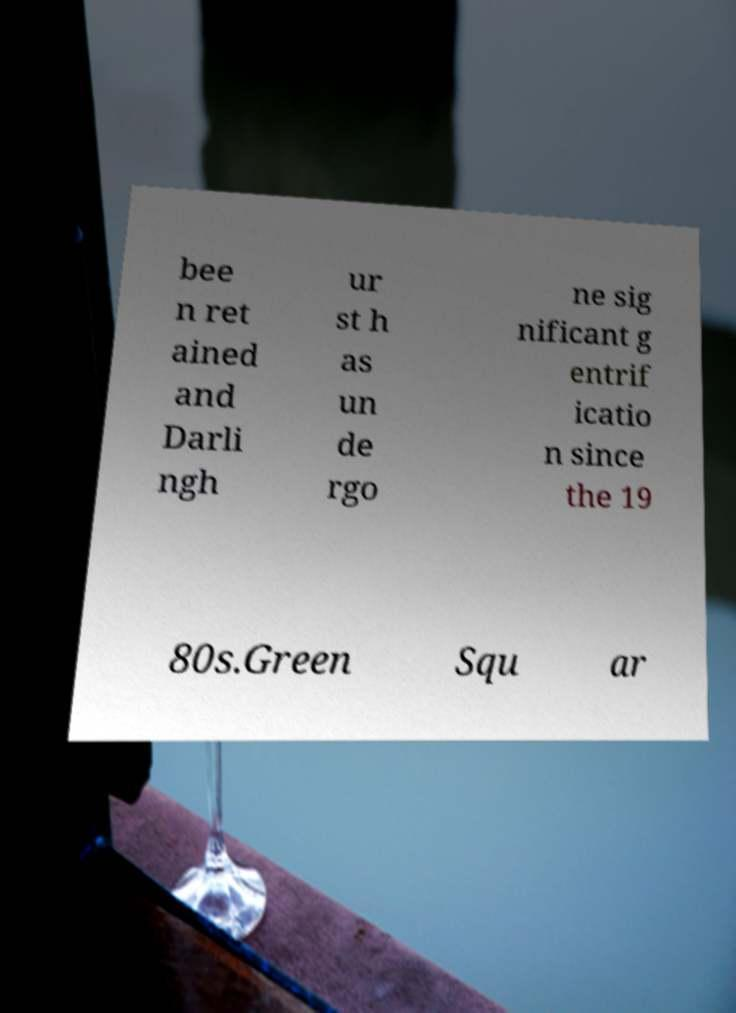Could you assist in decoding the text presented in this image and type it out clearly? bee n ret ained and Darli ngh ur st h as un de rgo ne sig nificant g entrif icatio n since the 19 80s.Green Squ ar 